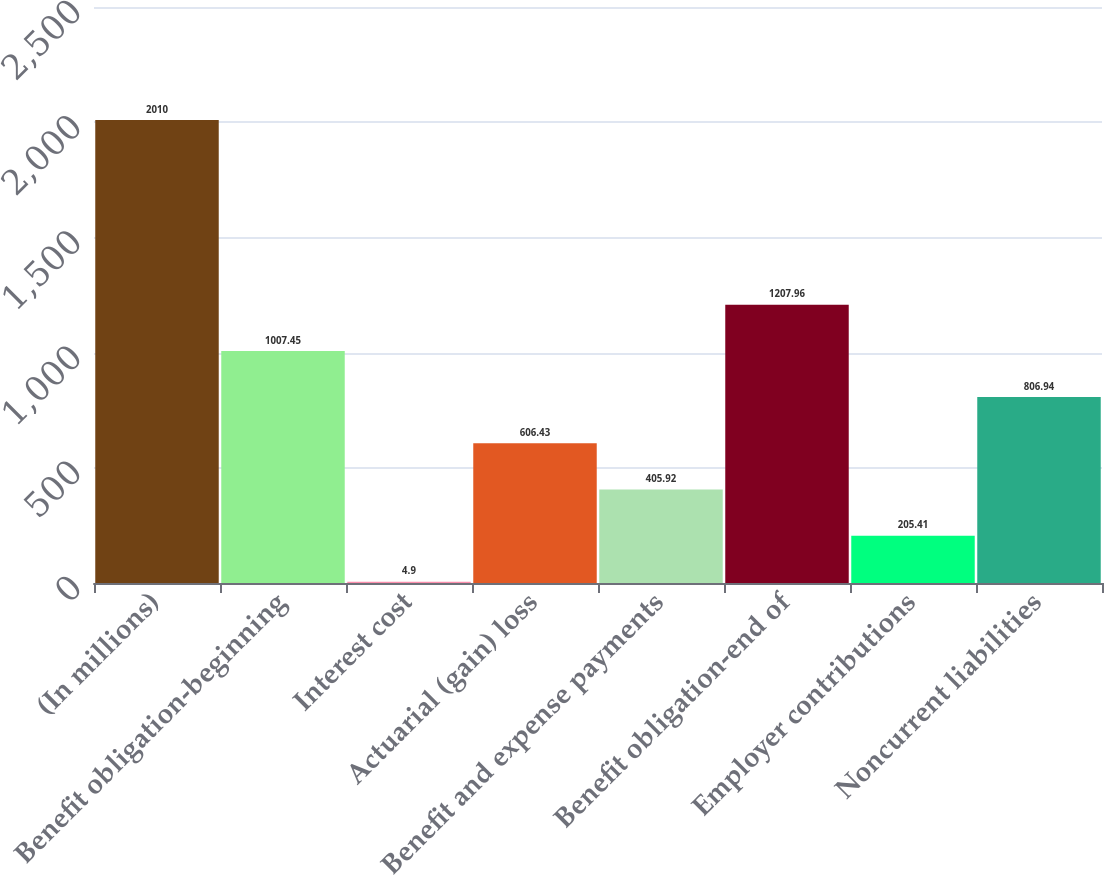Convert chart to OTSL. <chart><loc_0><loc_0><loc_500><loc_500><bar_chart><fcel>(In millions)<fcel>Benefit obligation-beginning<fcel>Interest cost<fcel>Actuarial (gain) loss<fcel>Benefit and expense payments<fcel>Benefit obligation-end of<fcel>Employer contributions<fcel>Noncurrent liabilities<nl><fcel>2010<fcel>1007.45<fcel>4.9<fcel>606.43<fcel>405.92<fcel>1207.96<fcel>205.41<fcel>806.94<nl></chart> 